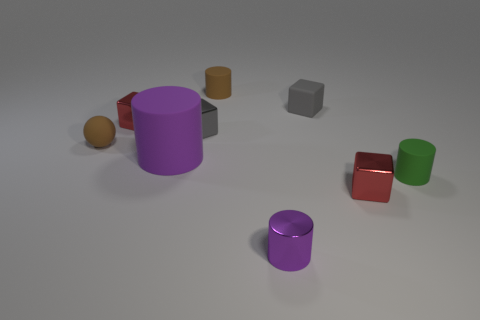Subtract 1 cylinders. How many cylinders are left? 3 Subtract all balls. How many objects are left? 8 Add 6 purple things. How many purple things are left? 8 Add 6 tiny gray metal things. How many tiny gray metal things exist? 7 Subtract 1 green cylinders. How many objects are left? 8 Subtract all tiny brown objects. Subtract all gray metal cubes. How many objects are left? 6 